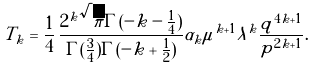Convert formula to latex. <formula><loc_0><loc_0><loc_500><loc_500>T _ { k } = \frac { 1 } { 4 } \, { \frac { { 2 } ^ { k } \sqrt { \pi } \Gamma ( - k - \frac { 1 } { 4 } ) } { \Gamma ( \frac { 3 } { 4 } ) \Gamma ( - k + \frac { 1 } { 2 } ) } } \alpha _ { k } \mu ^ { k + 1 } \lambda ^ { k } \frac { q ^ { 4 k + 1 } } { p ^ { 2 k + 1 } } .</formula> 